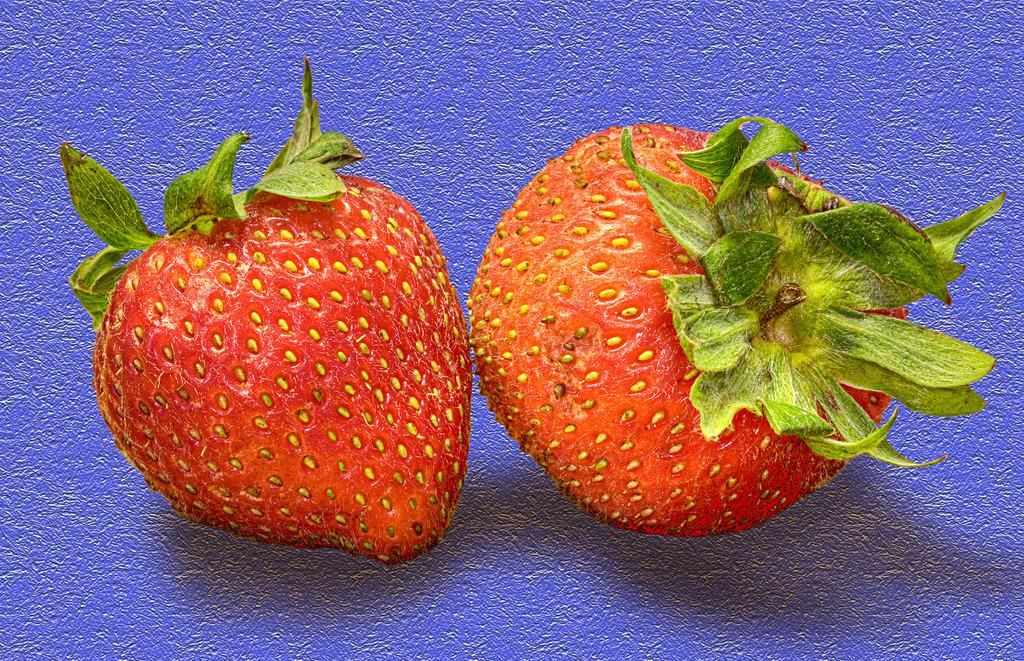How many strawberries are visible in the image? There are two strawberries in the image. What color are the strawberries? The strawberries are red. Are there any additional features on the strawberries? Yes, there are leaves on the strawberries. What is the color of the surface on which the strawberries are placed? The strawberries are placed on a purple surface. What is the weight of the strawberries in the image? The weight of the strawberries cannot be determined from the image alone. 